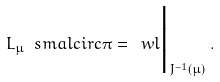<formula> <loc_0><loc_0><loc_500><loc_500>L _ { \mu } \ s m a l c i r c \pi = \ w l \Big | _ { J ^ { - 1 } ( \mu ) } \, .</formula> 